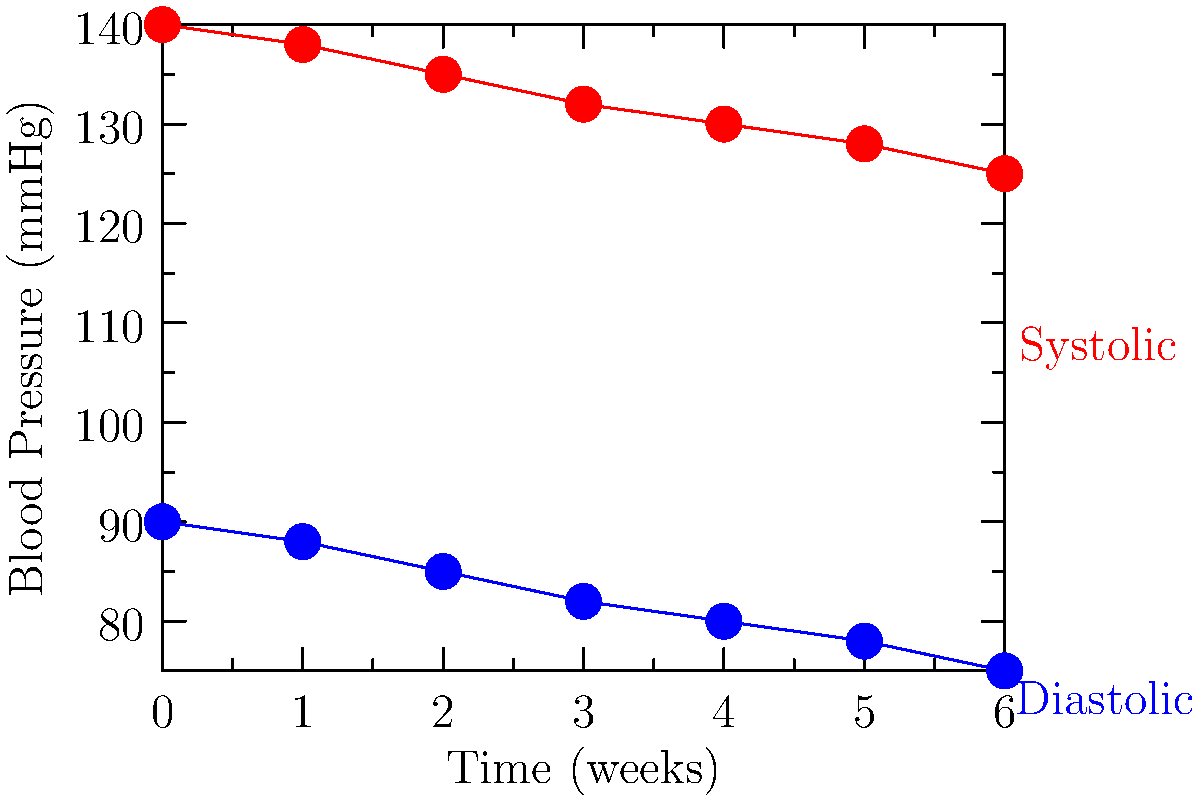As a nurse monitoring a patient's blood pressure over time, you observe the trends shown in the line graph. What is the average weekly reduction in systolic blood pressure over the 6-week period, and what might this indicate about the effectiveness of the patient's treatment plan? To answer this question, we need to follow these steps:

1. Identify the initial and final systolic blood pressure values:
   Initial (Week 0): 140 mmHg
   Final (Week 6): 125 mmHg

2. Calculate the total reduction in systolic blood pressure:
   Total reduction = Initial - Final = 140 mmHg - 125 mmHg = 15 mmHg

3. Calculate the average weekly reduction:
   Average weekly reduction = Total reduction / Number of weeks
   = 15 mmHg / 6 weeks = 2.5 mmHg/week

4. Interpret the results:
   The average weekly reduction of 2.5 mmHg in systolic blood pressure indicates a consistent downward trend. This suggests that the patient's treatment plan is likely effective in managing their hypertension.

5. Consider additional factors:
   - The diastolic pressure is also decreasing, which further supports the effectiveness of the treatment.
   - The gradual nature of the decrease is generally preferred, as it indicates a stable and sustainable improvement.
   - As a nurse, you would want to continue monitoring to ensure the trend continues and that the blood pressure reaches or maintains a healthy range (typically below 120/80 mmHg).
Answer: 2.5 mmHg/week; indicates effective treatment 